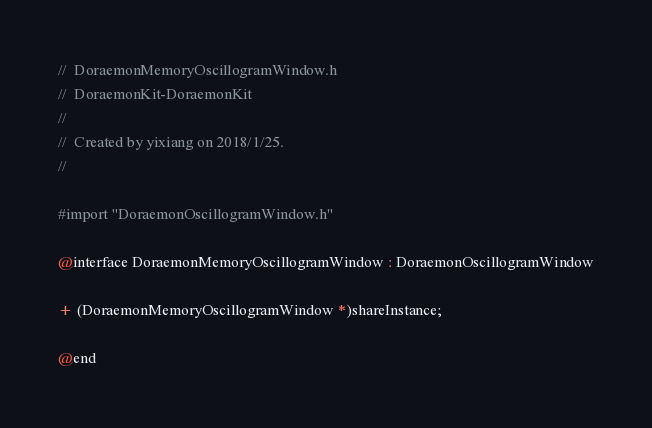<code> <loc_0><loc_0><loc_500><loc_500><_C_>//  DoraemonMemoryOscillogramWindow.h
//  DoraemonKit-DoraemonKit
//
//  Created by yixiang on 2018/1/25.
//

#import "DoraemonOscillogramWindow.h"

@interface DoraemonMemoryOscillogramWindow : DoraemonOscillogramWindow

+ (DoraemonMemoryOscillogramWindow *)shareInstance;

@end
</code> 